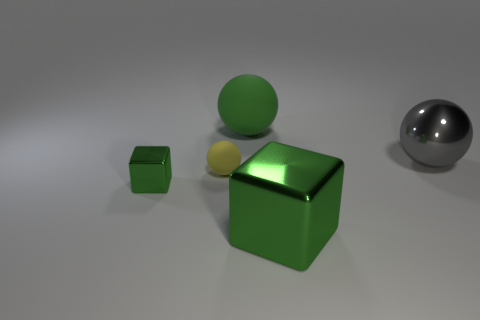The green thing that is in front of the large gray thing and behind the large green metallic object is made of what material?
Give a very brief answer. Metal. The gray shiny ball has what size?
Your response must be concise. Large. How many gray objects are on the right side of the green cube behind the thing that is in front of the tiny green thing?
Keep it short and to the point. 1. There is a big green thing left of the block in front of the tiny green metallic block; what is its shape?
Ensure brevity in your answer.  Sphere. What size is the green thing that is the same shape as the yellow matte object?
Ensure brevity in your answer.  Large. What is the color of the large ball behind the gray shiny object?
Your response must be concise. Green. The cube behind the large object that is in front of the large gray sphere in front of the large rubber ball is made of what material?
Offer a very short reply. Metal. There is a block left of the matte sphere that is in front of the gray sphere; how big is it?
Make the answer very short. Small. There is a large matte thing that is the same shape as the tiny matte object; what color is it?
Provide a succinct answer. Green. What number of tiny things have the same color as the big rubber thing?
Make the answer very short. 1. 